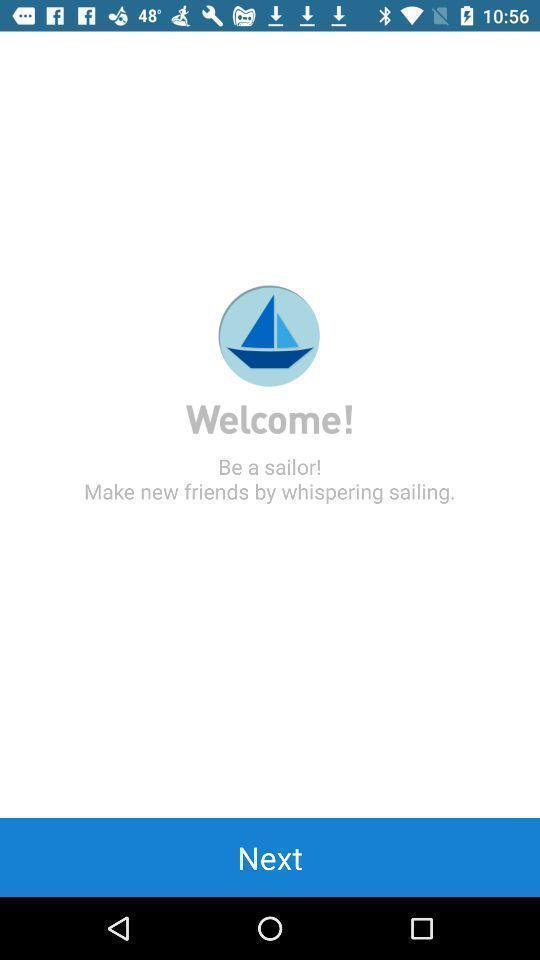Give me a narrative description of this picture. Welcome page of social app. 